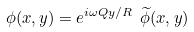<formula> <loc_0><loc_0><loc_500><loc_500>\phi ( x , y ) = e ^ { i \omega Q y / R } \ \widetilde { \phi } ( x , y )</formula> 